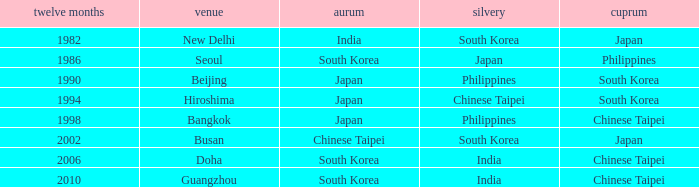Which Bronze has a Year smaller than 1994, and a Silver of south korea? Japan. 